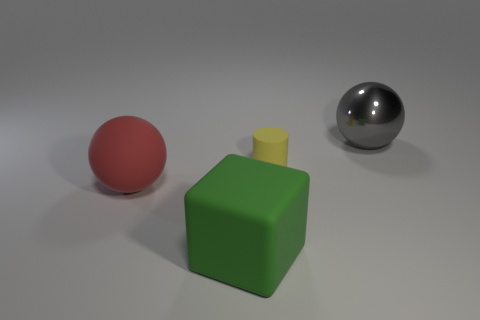Add 1 large spheres. How many objects exist? 5 Subtract all gray spheres. How many spheres are left? 1 Subtract all cubes. How many objects are left? 3 Add 2 large green rubber things. How many large green rubber things are left? 3 Add 4 matte cubes. How many matte cubes exist? 5 Subtract 0 yellow cubes. How many objects are left? 4 Subtract all brown spheres. Subtract all yellow cylinders. How many spheres are left? 2 Subtract all red cylinders. How many red spheres are left? 1 Subtract all green matte things. Subtract all red matte spheres. How many objects are left? 2 